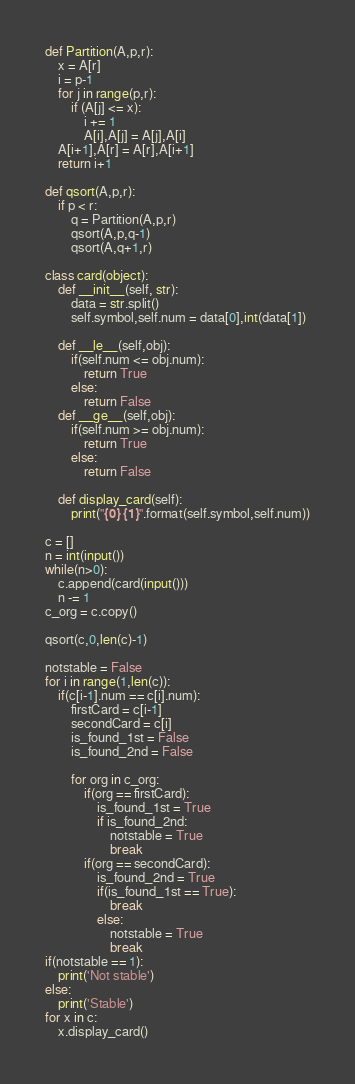<code> <loc_0><loc_0><loc_500><loc_500><_Python_>def Partition(A,p,r):
    x = A[r]
    i = p-1
    for j in range(p,r):
        if (A[j] <= x):
            i += 1
            A[i],A[j] = A[j],A[i]
    A[i+1],A[r] = A[r],A[i+1]
    return i+1

def qsort(A,p,r):
    if p < r:
        q = Partition(A,p,r)
        qsort(A,p,q-1)
        qsort(A,q+1,r)

class card(object):
    def __init__(self, str):
        data = str.split()
        self.symbol,self.num = data[0],int(data[1])
    
    def __le__(self,obj):
        if(self.num <= obj.num):
            return True
        else:
            return False
    def __ge__(self,obj):
        if(self.num >= obj.num):
            return True
        else:
            return False

    def display_card(self):
        print("{0} {1}".format(self.symbol,self.num))

c = []        
n = int(input())
while(n>0):
    c.append(card(input()))
    n -= 1
c_org = c.copy()

qsort(c,0,len(c)-1)

notstable = False
for i in range(1,len(c)):
    if(c[i-1].num == c[i].num):
        firstCard = c[i-1]
        secondCard = c[i]
        is_found_1st = False
        is_found_2nd = False

        for org in c_org:
            if(org == firstCard):
                is_found_1st = True
                if is_found_2nd:
                    notstable = True
                    break
            if(org == secondCard):
                is_found_2nd = True
                if(is_found_1st == True):
                    break
                else:
                    notstable = True
                    break
if(notstable == 1):
    print('Not stable')
else:
    print('Stable')
for x in c:
    x.display_card()</code> 